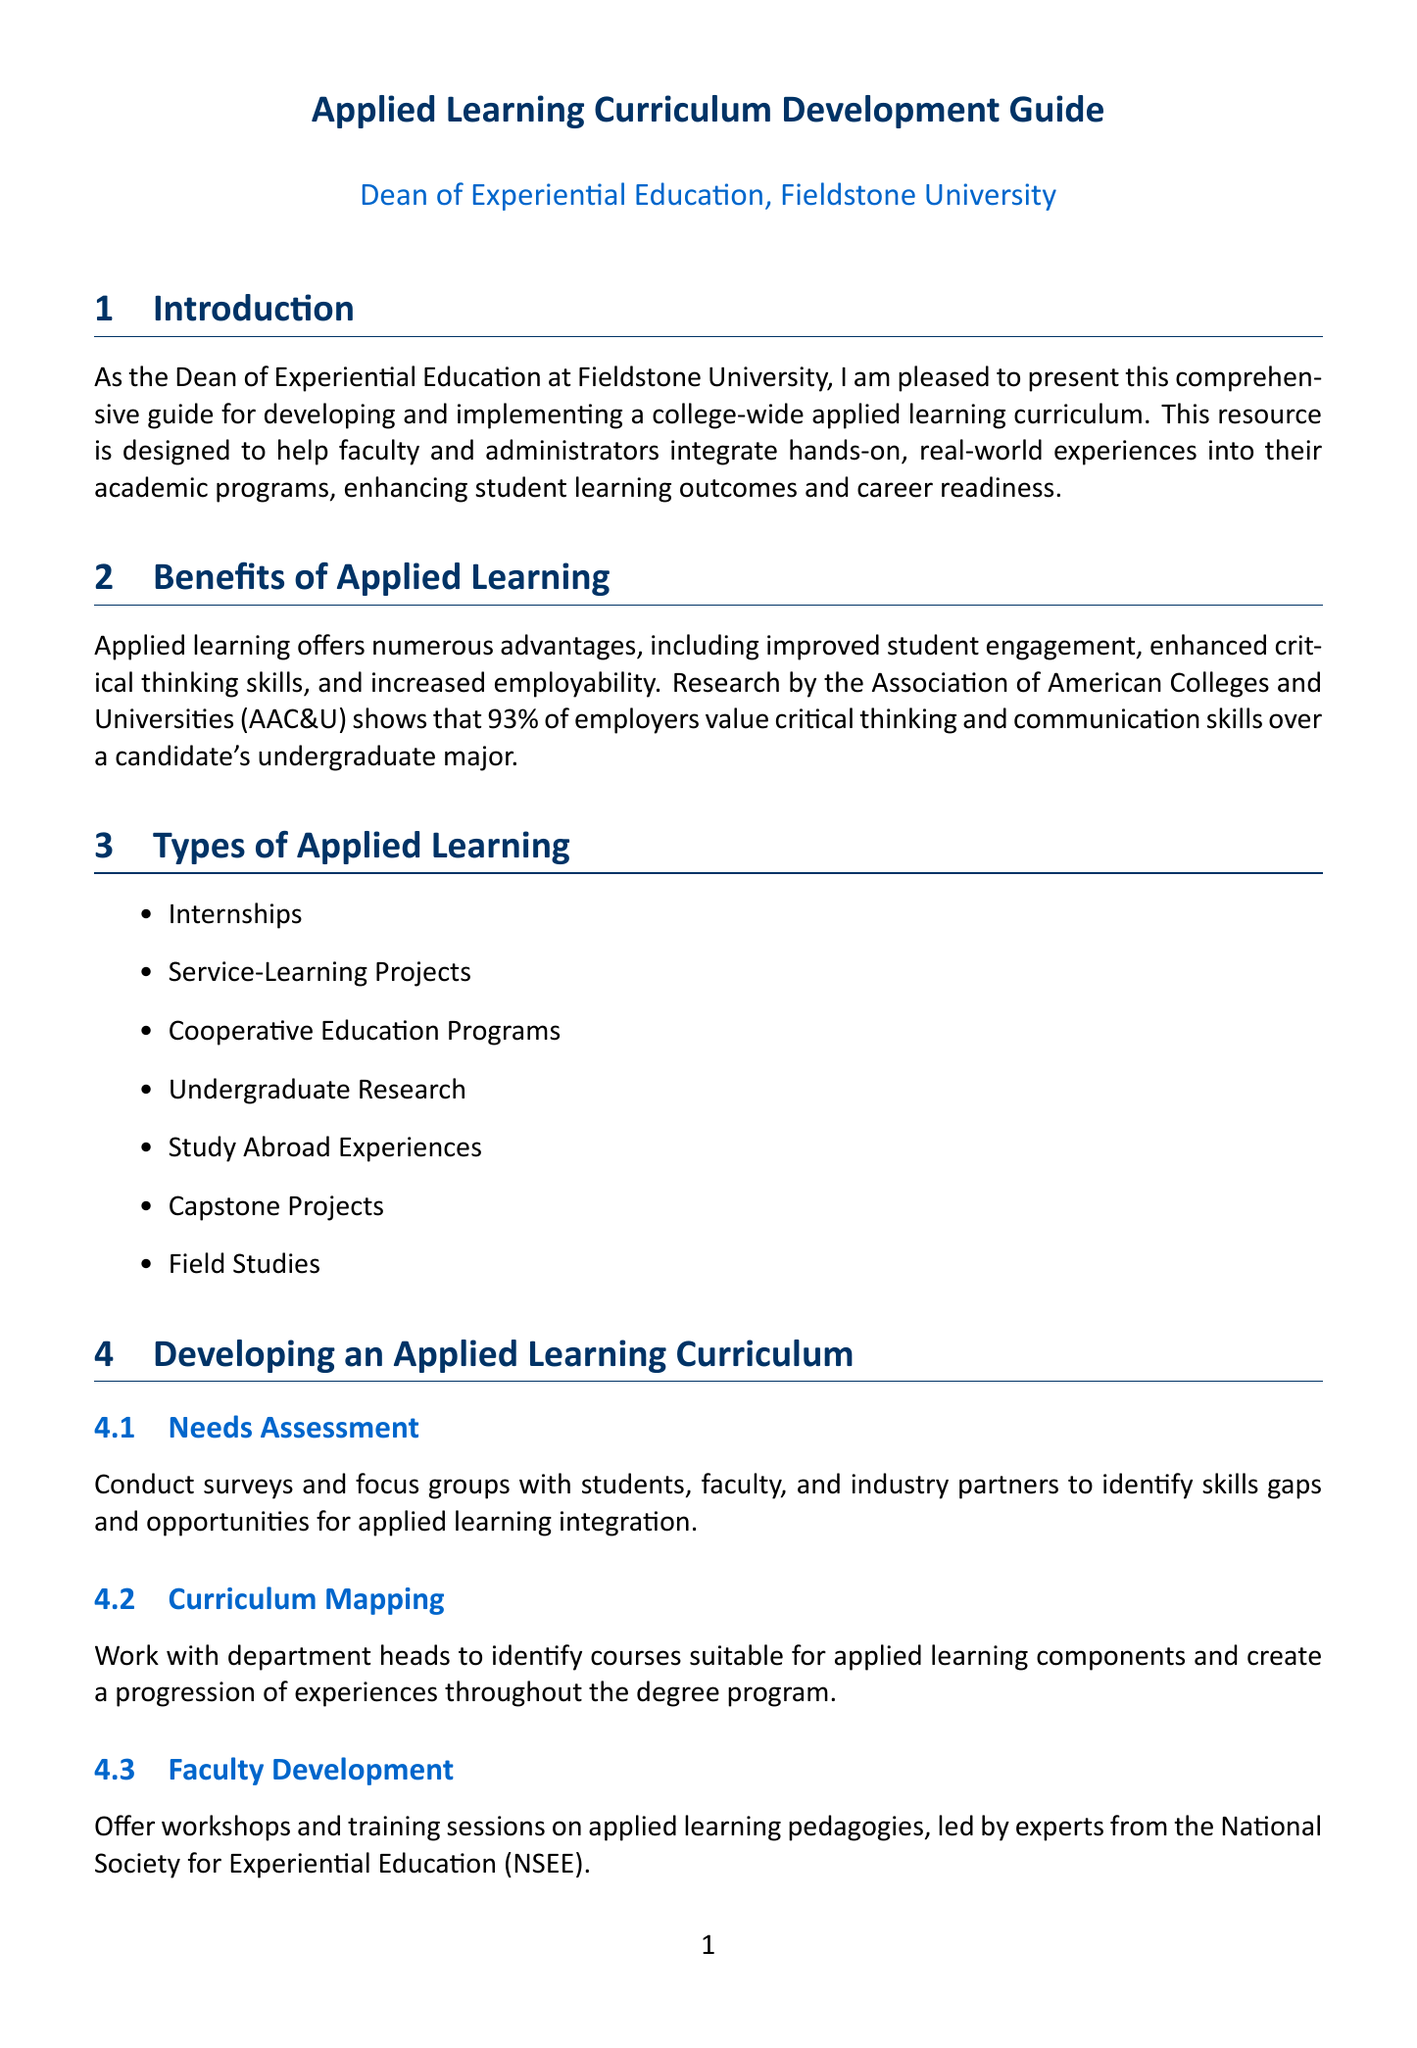What is the title of the guide? The title of the guide is mentioned at the top of the document.
Answer: Applied Learning Curriculum Development Guide Who is the author of the document? The author is specified in the document under the title.
Answer: Dean of Experiential Education, Fieldstone University How many phases are in the implementation timeline? The document lists three phases in the implementation timeline.
Answer: 3 What is one type of applied learning mentioned? The document lists several types of applied learning in a section.
Answer: Internships What are the two tools mentioned for evaluating student satisfaction? The document specifies the tools for student satisfaction within the evaluation metrics.
Answer: National Survey of Student Engagement (NSSE) What is the duration of the pilot implementation phase? The document clearly states the duration for the pilot implementation phase.
Answer: 1 academic year What is one method for faculty development? The document describes methods for faculty development in one of the subsections.
Answer: Workshops and training sessions Which metric assesses career readiness? The document identifies a specific metric related to career readiness in the evaluation metrics section.
Answer: Career Readiness 